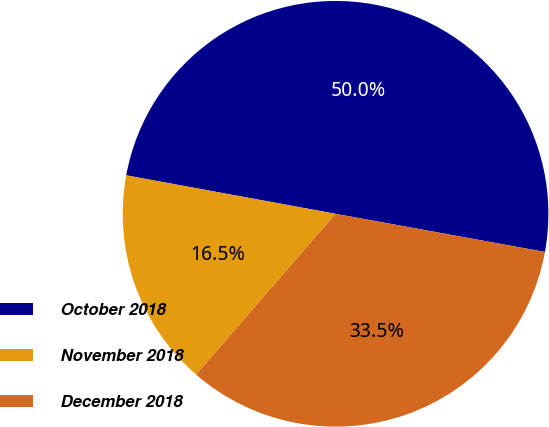Convert chart. <chart><loc_0><loc_0><loc_500><loc_500><pie_chart><fcel>October 2018<fcel>November 2018<fcel>December 2018<nl><fcel>49.97%<fcel>16.52%<fcel>33.5%<nl></chart> 